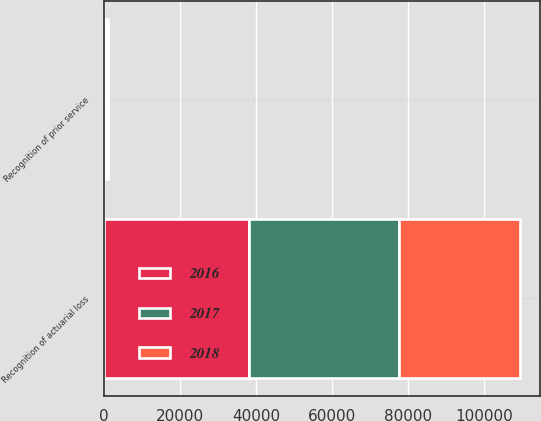<chart> <loc_0><loc_0><loc_500><loc_500><stacked_bar_chart><ecel><fcel>Recognition of actuarial loss<fcel>Recognition of prior service<nl><fcel>2017<fcel>39721<fcel>147<nl><fcel>2016<fcel>38034<fcel>350<nl><fcel>2018<fcel>31641<fcel>432<nl></chart> 